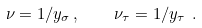<formula> <loc_0><loc_0><loc_500><loc_500>\nu = 1 / y _ { \sigma } \, , \quad \nu _ { \tau } = 1 / y _ { \tau } \ .</formula> 